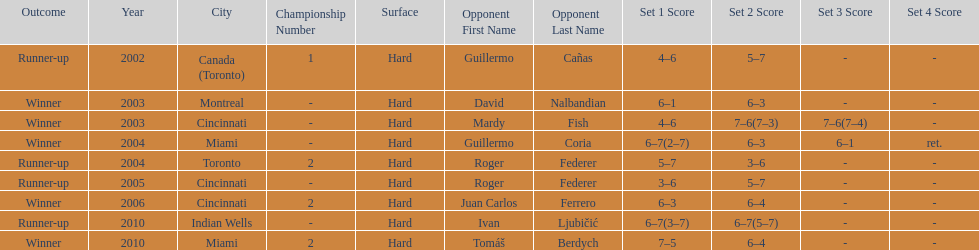How many times was roger federer a runner-up? 2. 